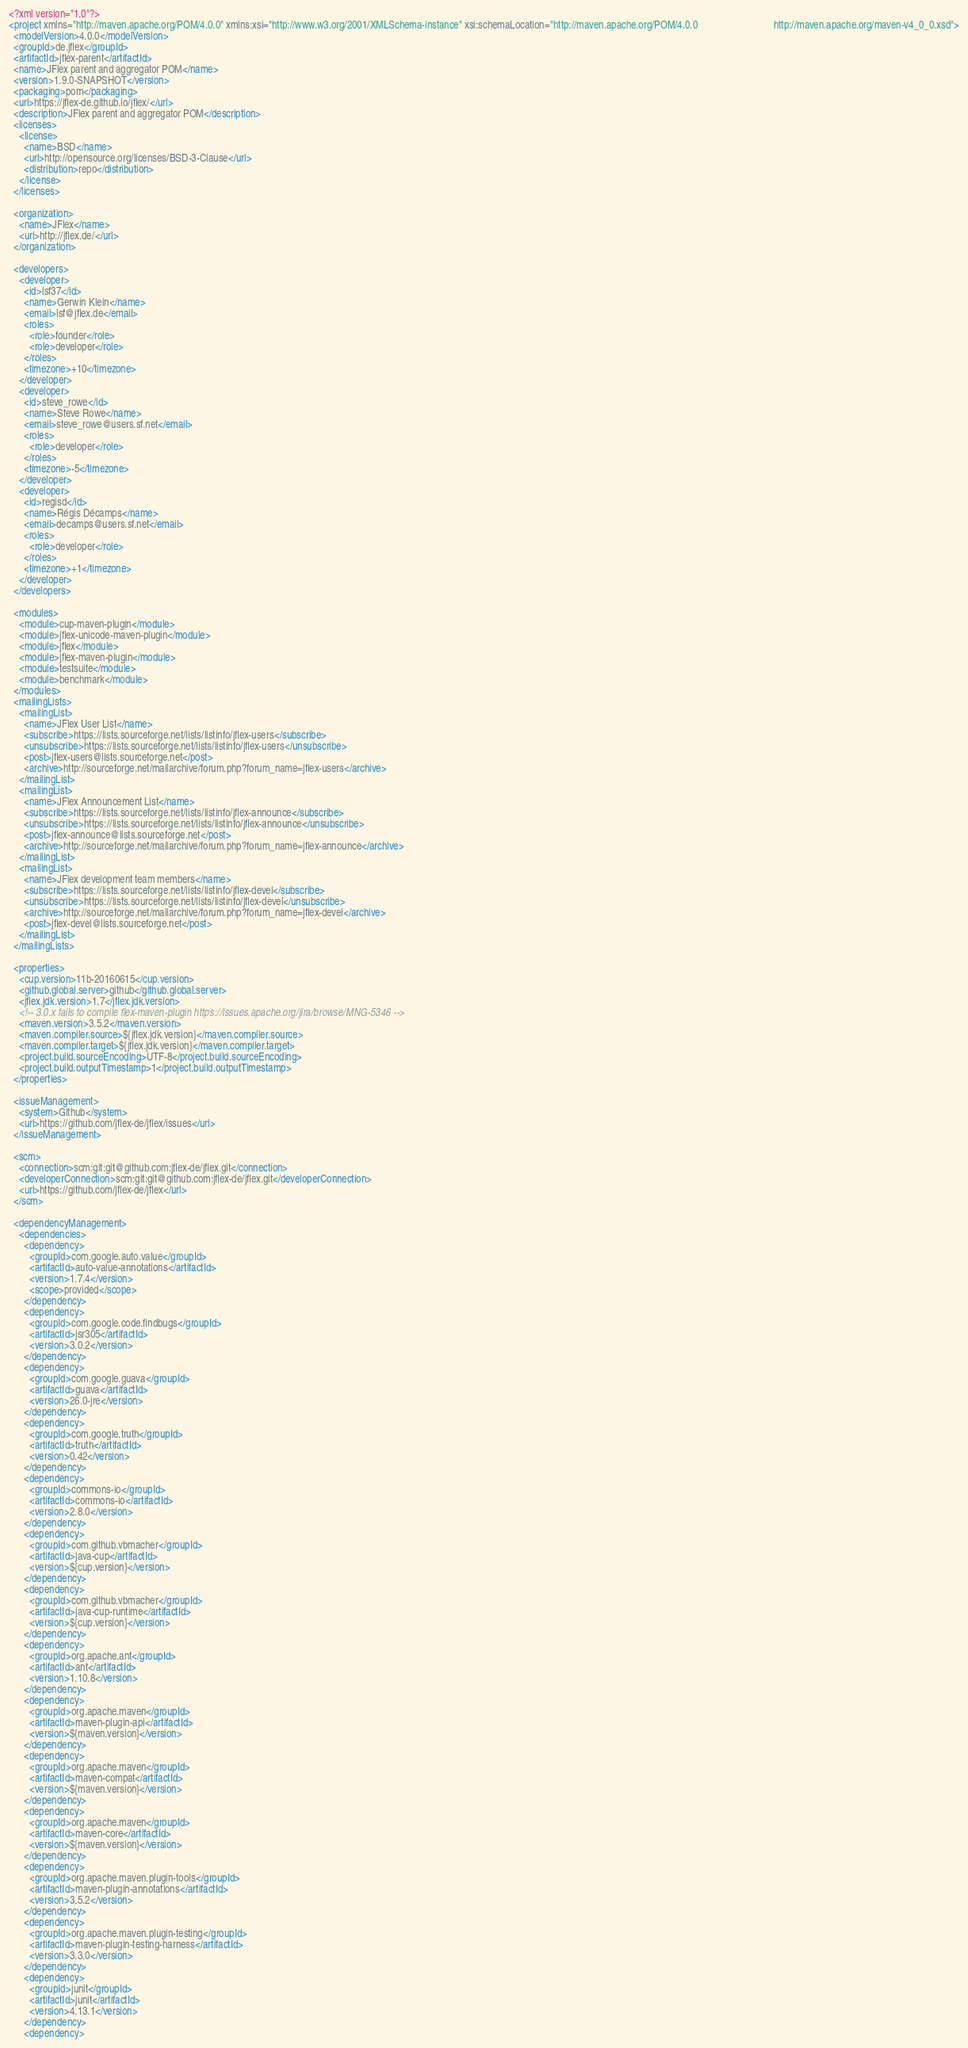Convert code to text. <code><loc_0><loc_0><loc_500><loc_500><_XML_><?xml version="1.0"?>
<project xmlns="http://maven.apache.org/POM/4.0.0" xmlns:xsi="http://www.w3.org/2001/XMLSchema-instance" xsi:schemaLocation="http://maven.apache.org/POM/4.0.0                              http://maven.apache.org/maven-v4_0_0.xsd">
  <modelVersion>4.0.0</modelVersion>
  <groupId>de.jflex</groupId>
  <artifactId>jflex-parent</artifactId>
  <name>JFlex parent and aggregator POM</name>
  <version>1.9.0-SNAPSHOT</version>
  <packaging>pom</packaging>
  <url>https://jflex-de.github.io/jflex/</url>
  <description>JFlex parent and aggregator POM</description>
  <licenses>
    <license>
      <name>BSD</name>
      <url>http://opensource.org/licenses/BSD-3-Clause</url>
      <distribution>repo</distribution>
    </license>
  </licenses>

  <organization>
    <name>JFlex</name>
    <url>http://jflex.de/</url>
  </organization>

  <developers>
    <developer>
      <id>lsf37</id>
      <name>Gerwin Klein</name>
      <email>lsf@jflex.de</email>
      <roles>
        <role>founder</role>
        <role>developer</role>
      </roles>
      <timezone>+10</timezone>
    </developer>
    <developer>
      <id>steve_rowe</id>
      <name>Steve Rowe</name>
      <email>steve_rowe@users.sf.net</email>
      <roles>
        <role>developer</role>
      </roles>
      <timezone>-5</timezone>
    </developer>
    <developer>
      <id>regisd</id>
      <name>Régis Décamps</name>
      <email>decamps@users.sf.net</email>
      <roles>
        <role>developer</role>
      </roles>
      <timezone>+1</timezone>
    </developer>
  </developers>

  <modules>
    <module>cup-maven-plugin</module>
    <module>jflex-unicode-maven-plugin</module>
    <module>jflex</module>
    <module>jflex-maven-plugin</module>
    <module>testsuite</module>
    <module>benchmark</module>
  </modules>
  <mailingLists>
    <mailingList>
      <name>JFlex User List</name>
      <subscribe>https://lists.sourceforge.net/lists/listinfo/jflex-users</subscribe>
      <unsubscribe>https://lists.sourceforge.net/lists/listinfo/jflex-users</unsubscribe>
      <post>jflex-users@lists.sourceforge.net</post>
      <archive>http://sourceforge.net/mailarchive/forum.php?forum_name=jflex-users</archive>
    </mailingList>
    <mailingList>
      <name>JFlex Announcement List</name>
      <subscribe>https://lists.sourceforge.net/lists/listinfo/jflex-announce</subscribe>
      <unsubscribe>https://lists.sourceforge.net/lists/listinfo/jflex-announce</unsubscribe>
      <post>jflex-announce@lists.sourceforge.net</post>
      <archive>http://sourceforge.net/mailarchive/forum.php?forum_name=jflex-announce</archive>
    </mailingList>
    <mailingList>
      <name>JFlex development team members</name>
      <subscribe>https://lists.sourceforge.net/lists/listinfo/jflex-devel</subscribe>
      <unsubscribe>https://lists.sourceforge.net/lists/listinfo/jflex-devel</unsubscribe>
      <archive>http://sourceforge.net/mailarchive/forum.php?forum_name=jflex-devel</archive>
      <post>jflex-devel@lists.sourceforge.net</post>
    </mailingList>
  </mailingLists>

  <properties>
    <cup.version>11b-20160615</cup.version>
    <github.global.server>github</github.global.server>
    <jflex.jdk.version>1.7</jflex.jdk.version>
    <!-- 3.0.x fails to compile flex-maven-plugin https://issues.apache.org/jira/browse/MNG-5346 -->
    <maven.version>3.5.2</maven.version>
    <maven.compiler.source>${jflex.jdk.version}</maven.compiler.source>
    <maven.compiler.target>${jflex.jdk.version}</maven.compiler.target>
    <project.build.sourceEncoding>UTF-8</project.build.sourceEncoding>
    <project.build.outputTimestamp>1</project.build.outputTimestamp>
  </properties>

  <issueManagement>
    <system>Github</system>
    <url>https://github.com/jflex-de/jflex/issues</url>
  </issueManagement>

  <scm>
    <connection>scm:git:git@github.com:jflex-de/jflex.git</connection>
    <developerConnection>scm:git:git@github.com:jflex-de/jflex.git</developerConnection>
    <url>https://github.com/jflex-de/jflex</url>
  </scm>

  <dependencyManagement>
    <dependencies>
      <dependency>
        <groupId>com.google.auto.value</groupId>
        <artifactId>auto-value-annotations</artifactId>
        <version>1.7.4</version>
        <scope>provided</scope>
      </dependency>
      <dependency>
        <groupId>com.google.code.findbugs</groupId>
        <artifactId>jsr305</artifactId>
        <version>3.0.2</version>
      </dependency>
      <dependency>
        <groupId>com.google.guava</groupId>
        <artifactId>guava</artifactId>
        <version>26.0-jre</version>
      </dependency>
      <dependency>
        <groupId>com.google.truth</groupId>
        <artifactId>truth</artifactId>
        <version>0.42</version>
      </dependency>
      <dependency>
        <groupId>commons-io</groupId>
        <artifactId>commons-io</artifactId>
        <version>2.8.0</version>
      </dependency>
      <dependency>
        <groupId>com.github.vbmacher</groupId>
        <artifactId>java-cup</artifactId>
        <version>${cup.version}</version>
      </dependency>
      <dependency>
        <groupId>com.github.vbmacher</groupId>
        <artifactId>java-cup-runtime</artifactId>
        <version>${cup.version}</version>
      </dependency>
      <dependency>
        <groupId>org.apache.ant</groupId>
        <artifactId>ant</artifactId>
        <version>1.10.8</version>
      </dependency>
      <dependency>
        <groupId>org.apache.maven</groupId>
        <artifactId>maven-plugin-api</artifactId>
        <version>${maven.version}</version>
      </dependency>
      <dependency>
        <groupId>org.apache.maven</groupId>
        <artifactId>maven-compat</artifactId>
        <version>${maven.version}</version>
      </dependency>
      <dependency>
        <groupId>org.apache.maven</groupId>
        <artifactId>maven-core</artifactId>
        <version>${maven.version}</version>
      </dependency>
      <dependency>
        <groupId>org.apache.maven.plugin-tools</groupId>
        <artifactId>maven-plugin-annotations</artifactId>
        <version>3.5.2</version>
      </dependency>
      <dependency>
        <groupId>org.apache.maven.plugin-testing</groupId>
        <artifactId>maven-plugin-testing-harness</artifactId>
        <version>3.3.0</version>
      </dependency>
      <dependency>
        <groupId>junit</groupId>
        <artifactId>junit</artifactId>
        <version>4.13.1</version>
      </dependency>
      <dependency></code> 